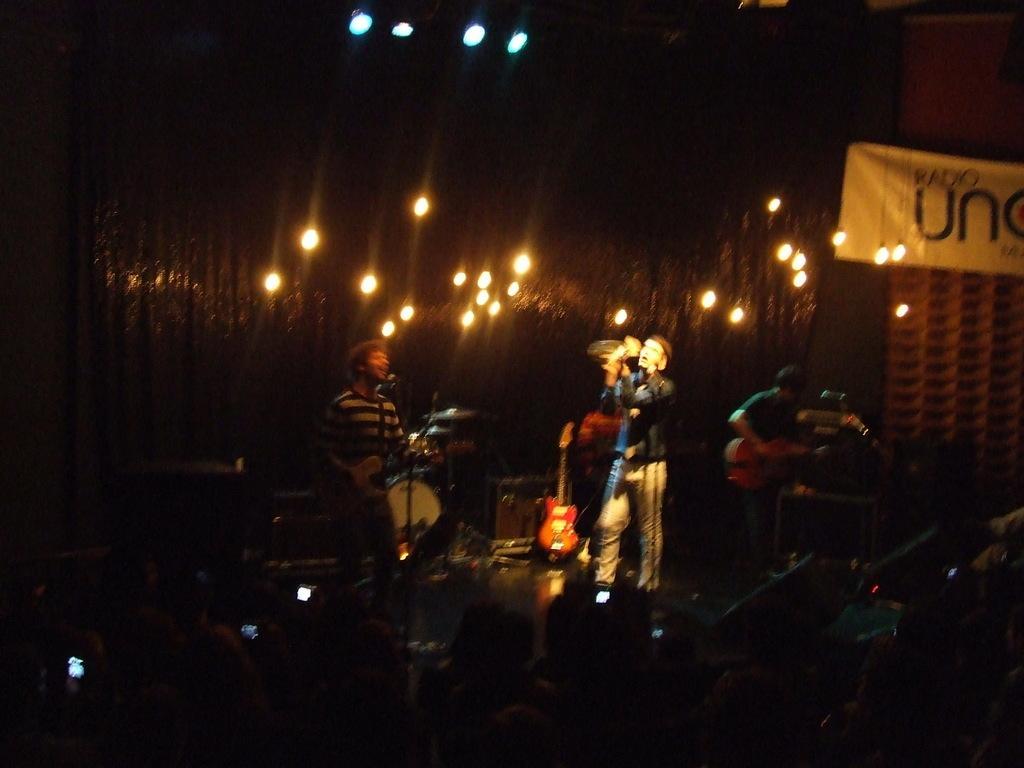In one or two sentences, can you explain what this image depicts? In this picture there are boys those who are performing music on the stage and there are lights in the center of the image, stage contains drum set, guitar, and mics. 